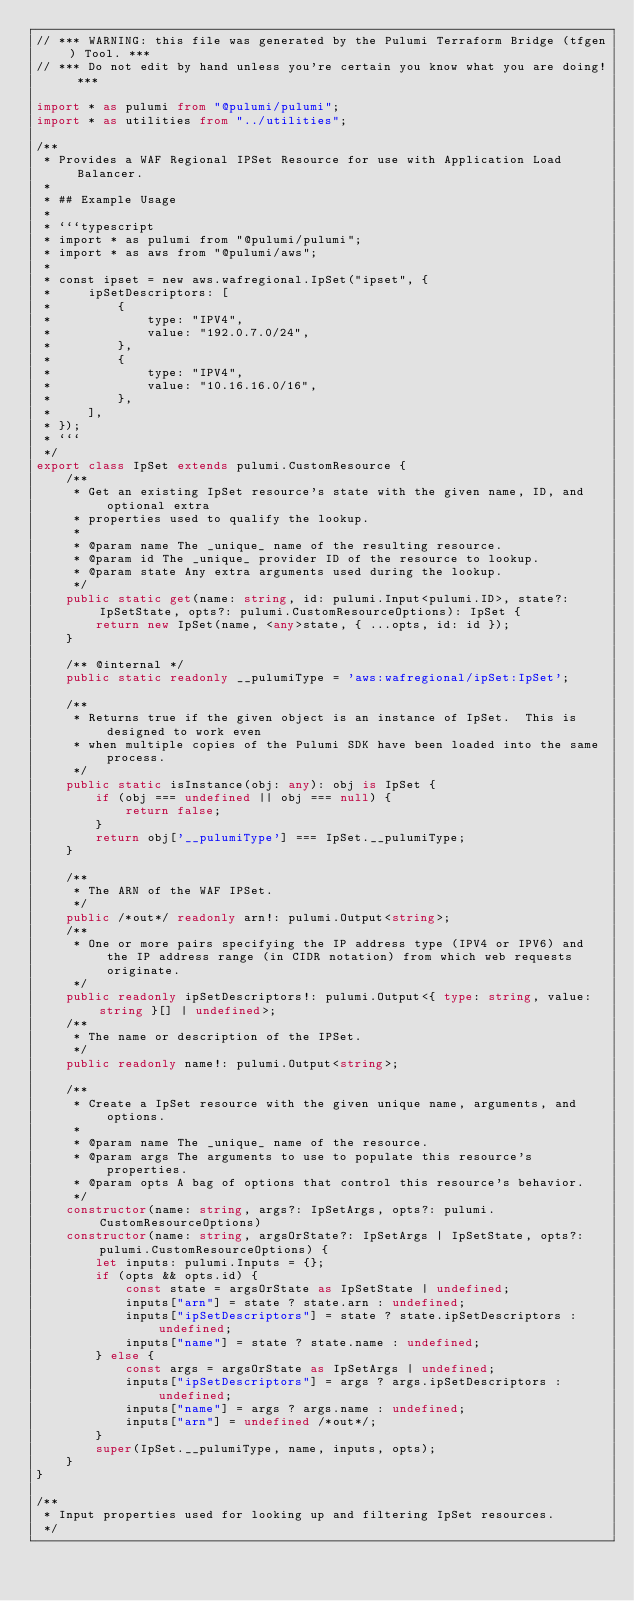<code> <loc_0><loc_0><loc_500><loc_500><_TypeScript_>// *** WARNING: this file was generated by the Pulumi Terraform Bridge (tfgen) Tool. ***
// *** Do not edit by hand unless you're certain you know what you are doing! ***

import * as pulumi from "@pulumi/pulumi";
import * as utilities from "../utilities";

/**
 * Provides a WAF Regional IPSet Resource for use with Application Load Balancer.
 * 
 * ## Example Usage
 * 
 * ```typescript
 * import * as pulumi from "@pulumi/pulumi";
 * import * as aws from "@pulumi/aws";
 * 
 * const ipset = new aws.wafregional.IpSet("ipset", {
 *     ipSetDescriptors: [
 *         {
 *             type: "IPV4",
 *             value: "192.0.7.0/24",
 *         },
 *         {
 *             type: "IPV4",
 *             value: "10.16.16.0/16",
 *         },
 *     ],
 * });
 * ```
 */
export class IpSet extends pulumi.CustomResource {
    /**
     * Get an existing IpSet resource's state with the given name, ID, and optional extra
     * properties used to qualify the lookup.
     *
     * @param name The _unique_ name of the resulting resource.
     * @param id The _unique_ provider ID of the resource to lookup.
     * @param state Any extra arguments used during the lookup.
     */
    public static get(name: string, id: pulumi.Input<pulumi.ID>, state?: IpSetState, opts?: pulumi.CustomResourceOptions): IpSet {
        return new IpSet(name, <any>state, { ...opts, id: id });
    }

    /** @internal */
    public static readonly __pulumiType = 'aws:wafregional/ipSet:IpSet';

    /**
     * Returns true if the given object is an instance of IpSet.  This is designed to work even
     * when multiple copies of the Pulumi SDK have been loaded into the same process.
     */
    public static isInstance(obj: any): obj is IpSet {
        if (obj === undefined || obj === null) {
            return false;
        }
        return obj['__pulumiType'] === IpSet.__pulumiType;
    }

    /**
     * The ARN of the WAF IPSet.
     */
    public /*out*/ readonly arn!: pulumi.Output<string>;
    /**
     * One or more pairs specifying the IP address type (IPV4 or IPV6) and the IP address range (in CIDR notation) from which web requests originate.
     */
    public readonly ipSetDescriptors!: pulumi.Output<{ type: string, value: string }[] | undefined>;
    /**
     * The name or description of the IPSet.
     */
    public readonly name!: pulumi.Output<string>;

    /**
     * Create a IpSet resource with the given unique name, arguments, and options.
     *
     * @param name The _unique_ name of the resource.
     * @param args The arguments to use to populate this resource's properties.
     * @param opts A bag of options that control this resource's behavior.
     */
    constructor(name: string, args?: IpSetArgs, opts?: pulumi.CustomResourceOptions)
    constructor(name: string, argsOrState?: IpSetArgs | IpSetState, opts?: pulumi.CustomResourceOptions) {
        let inputs: pulumi.Inputs = {};
        if (opts && opts.id) {
            const state = argsOrState as IpSetState | undefined;
            inputs["arn"] = state ? state.arn : undefined;
            inputs["ipSetDescriptors"] = state ? state.ipSetDescriptors : undefined;
            inputs["name"] = state ? state.name : undefined;
        } else {
            const args = argsOrState as IpSetArgs | undefined;
            inputs["ipSetDescriptors"] = args ? args.ipSetDescriptors : undefined;
            inputs["name"] = args ? args.name : undefined;
            inputs["arn"] = undefined /*out*/;
        }
        super(IpSet.__pulumiType, name, inputs, opts);
    }
}

/**
 * Input properties used for looking up and filtering IpSet resources.
 */</code> 